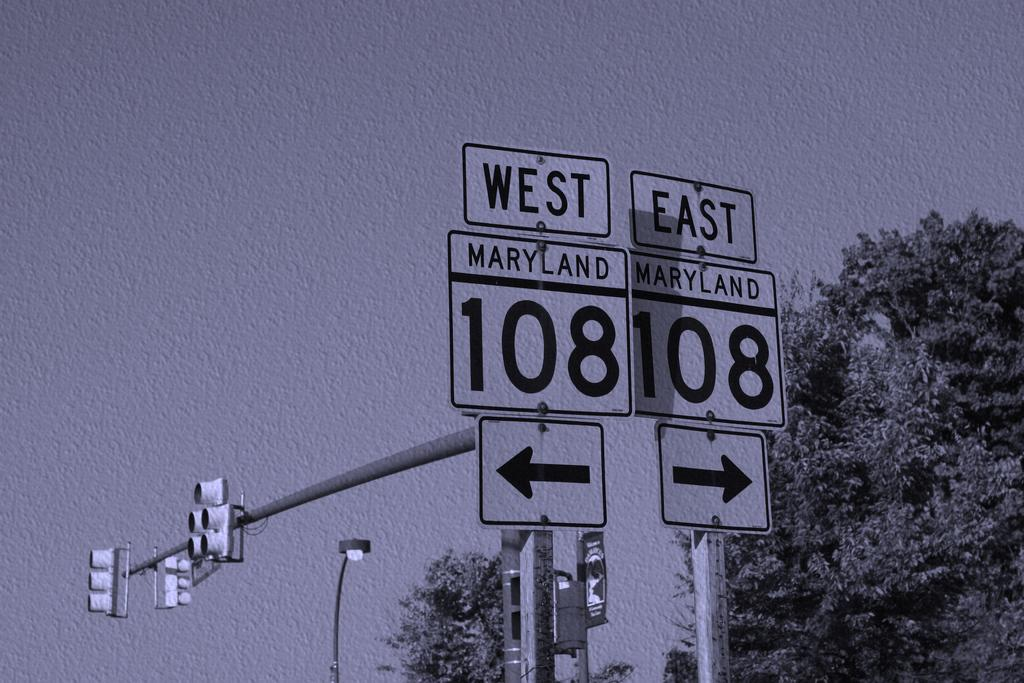What is present on the wall in the image? There is art on the wall, including sign boards, poles, signal lights, and lights. What else can be seen in the image besides the wall and its art? Trees are visible in the image. What type of coil is being used for driving in the image? There is no coil or driving activity present in the image. How many corks are visible in the image? There are no corks visible in the image. 